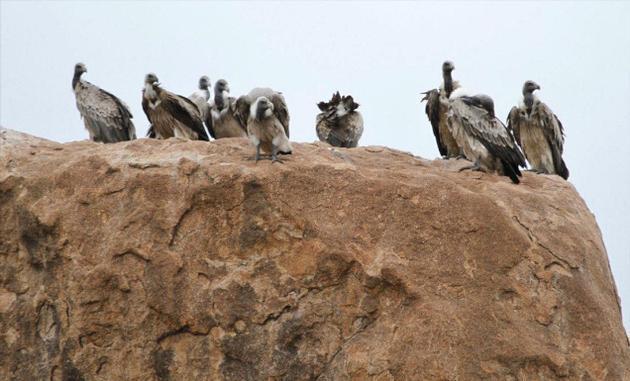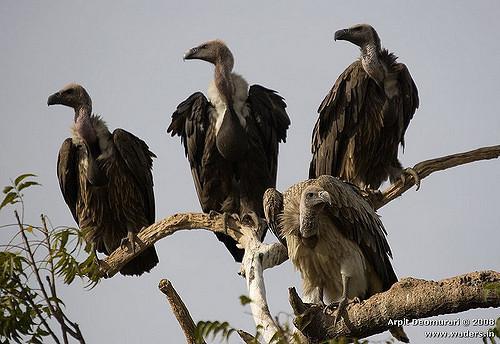The first image is the image on the left, the second image is the image on the right. Given the left and right images, does the statement "The sky can be seen in the image on the left" hold true? Answer yes or no. Yes. The first image is the image on the left, the second image is the image on the right. Given the left and right images, does the statement "An image features no more than four birds gathered around a carcass." hold true? Answer yes or no. No. 